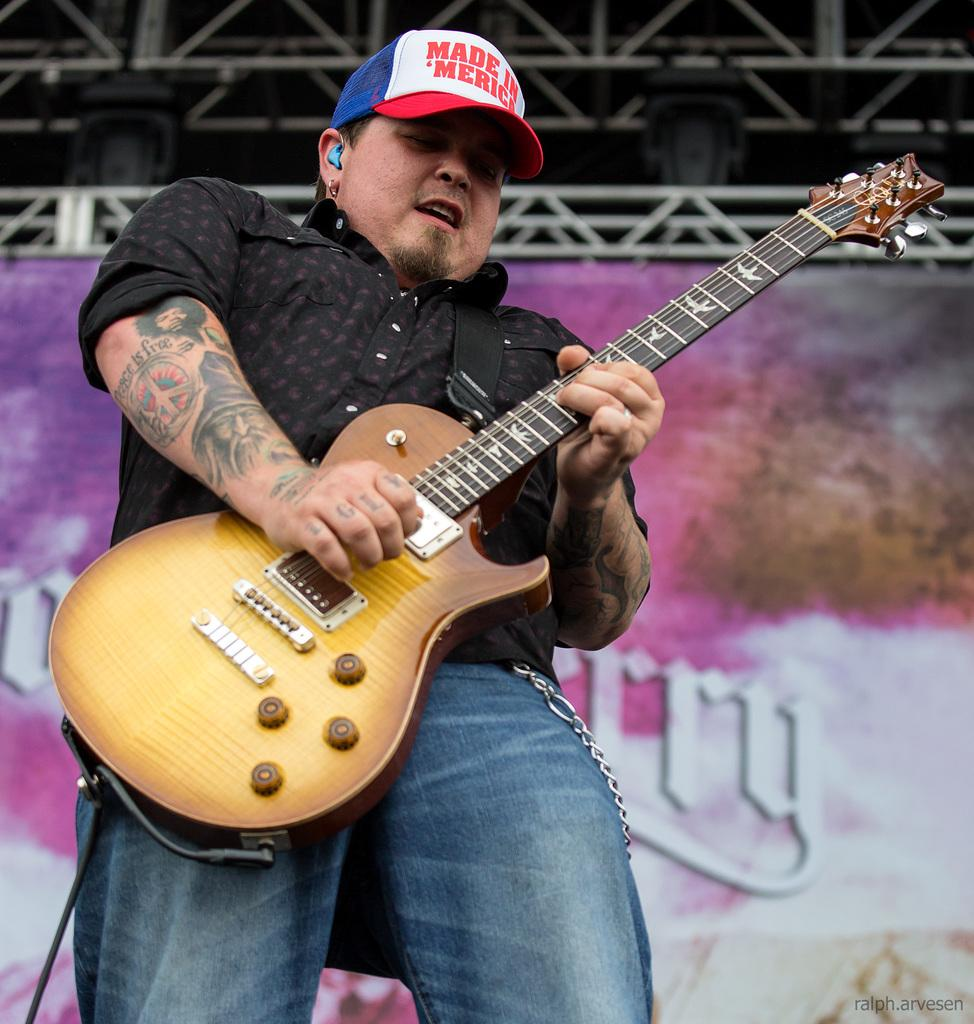What is the main subject of the image? The main subject of the image is a man. What is the man holding in his hand? The man is holding a guitar in his hand. What type of force is being applied to the blade in the image? There is no blade present in the image, so it is not possible to determine if any force is being applied to it. 